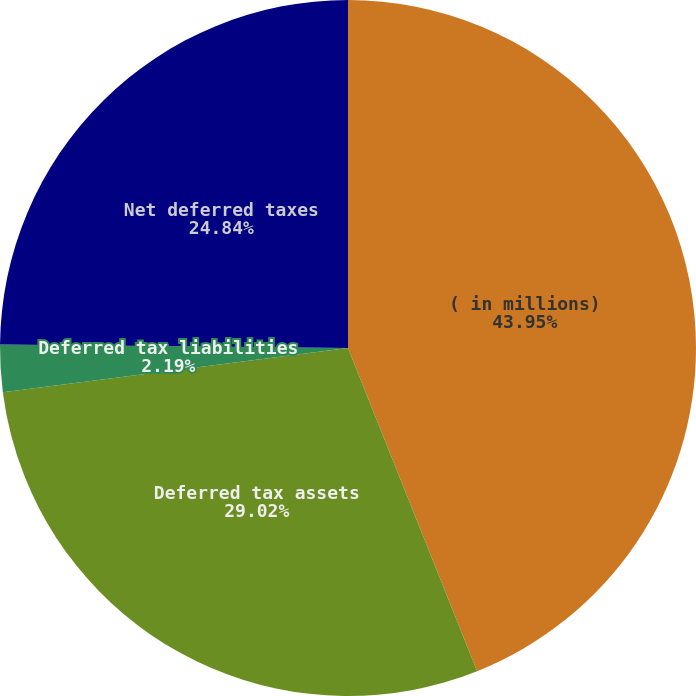Convert chart. <chart><loc_0><loc_0><loc_500><loc_500><pie_chart><fcel>( in millions)<fcel>Deferred tax assets<fcel>Deferred tax liabilities<fcel>Net deferred taxes<nl><fcel>43.95%<fcel>29.02%<fcel>2.19%<fcel>24.84%<nl></chart> 